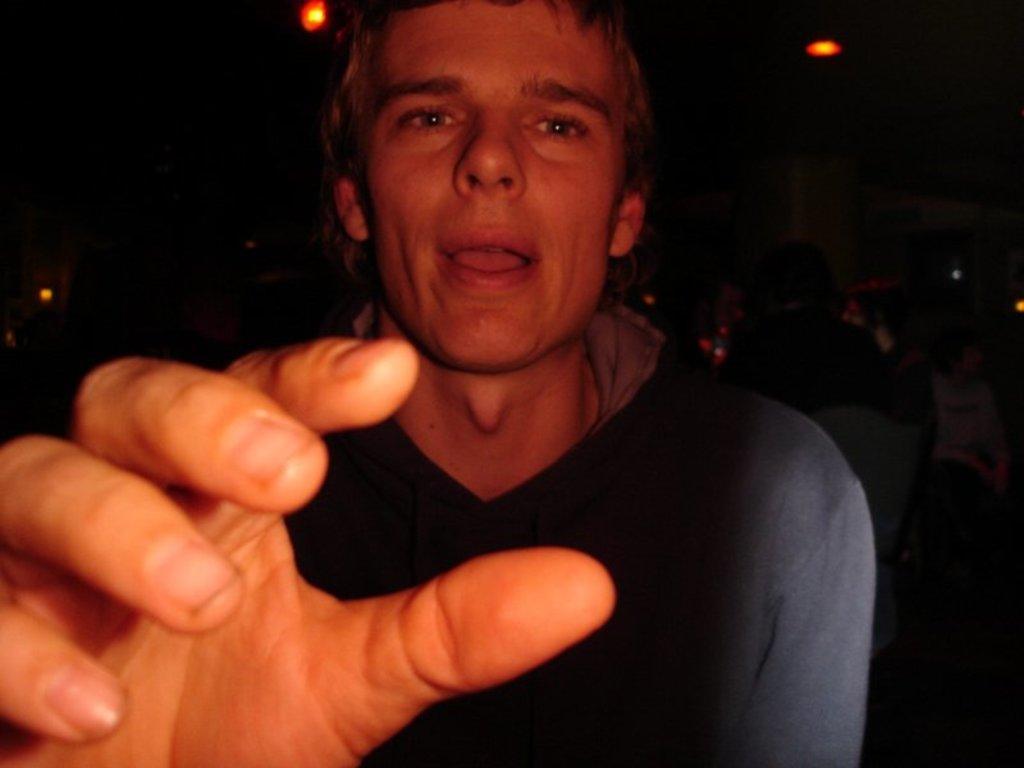In one or two sentences, can you explain what this image depicts? In this image, I can see the man. He wore a T-shirt. In the background, I can see a person sitting on the chair. These are the lights. 